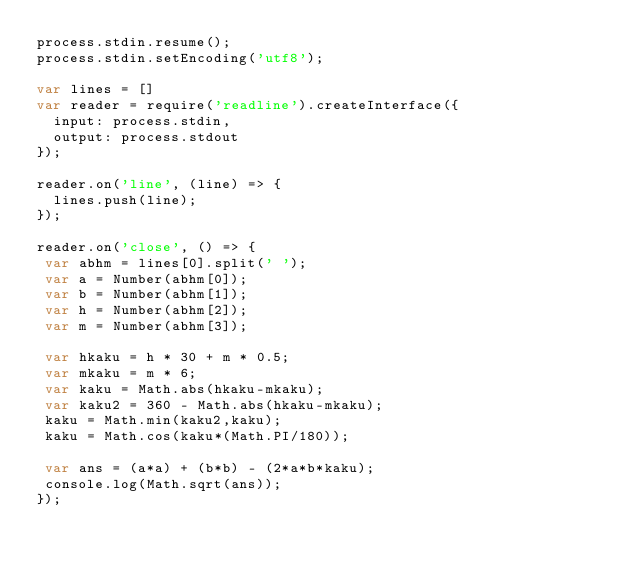<code> <loc_0><loc_0><loc_500><loc_500><_JavaScript_>process.stdin.resume();
process.stdin.setEncoding('utf8');

var lines = []
var reader = require('readline').createInterface({
  input: process.stdin,
  output: process.stdout
});

reader.on('line', (line) => {
  lines.push(line);
});

reader.on('close', () => {
 var abhm = lines[0].split(' ');
 var a = Number(abhm[0]);
 var b = Number(abhm[1]);
 var h = Number(abhm[2]);
 var m = Number(abhm[3]);

 var hkaku = h * 30 + m * 0.5;
 var mkaku = m * 6;
 var kaku = Math.abs(hkaku-mkaku);
 var kaku2 = 360 - Math.abs(hkaku-mkaku);
 kaku = Math.min(kaku2,kaku);
 kaku = Math.cos(kaku*(Math.PI/180));

 var ans = (a*a) + (b*b) - (2*a*b*kaku);
 console.log(Math.sqrt(ans));
});
</code> 